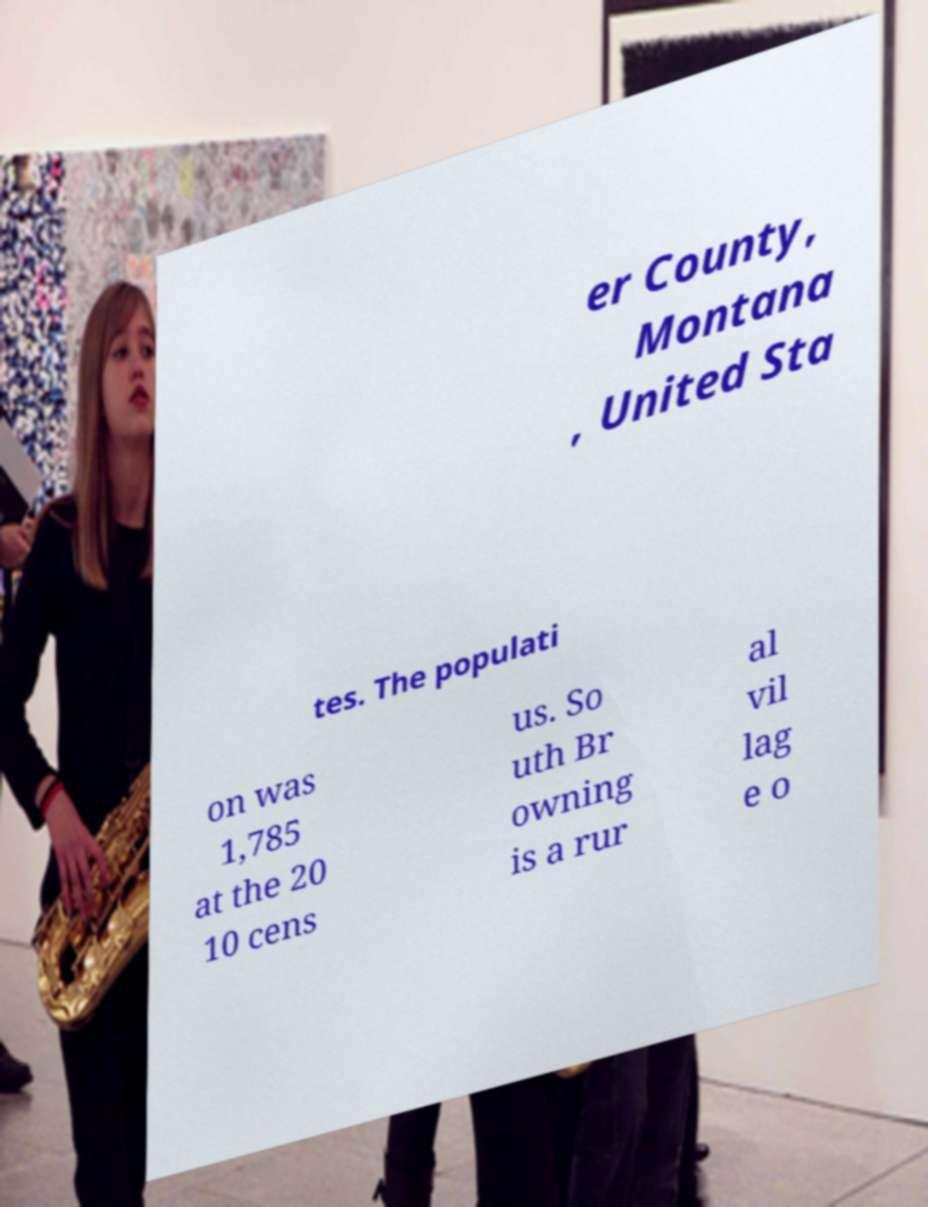Can you accurately transcribe the text from the provided image for me? er County, Montana , United Sta tes. The populati on was 1,785 at the 20 10 cens us. So uth Br owning is a rur al vil lag e o 